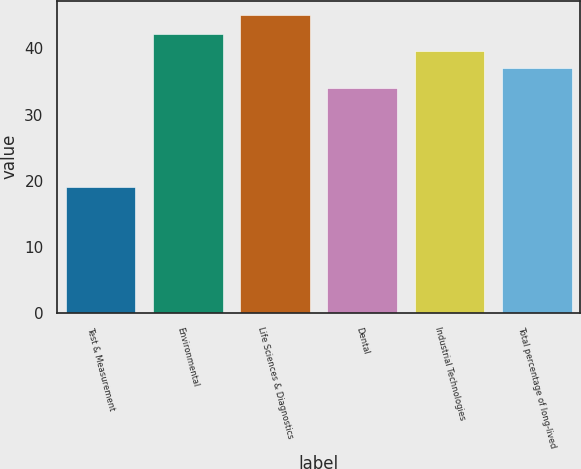Convert chart to OTSL. <chart><loc_0><loc_0><loc_500><loc_500><bar_chart><fcel>Test & Measurement<fcel>Environmental<fcel>Life Sciences & Diagnostics<fcel>Dental<fcel>Industrial Technologies<fcel>Total percentage of long-lived<nl><fcel>19<fcel>42.2<fcel>45<fcel>34<fcel>39.6<fcel>37<nl></chart> 